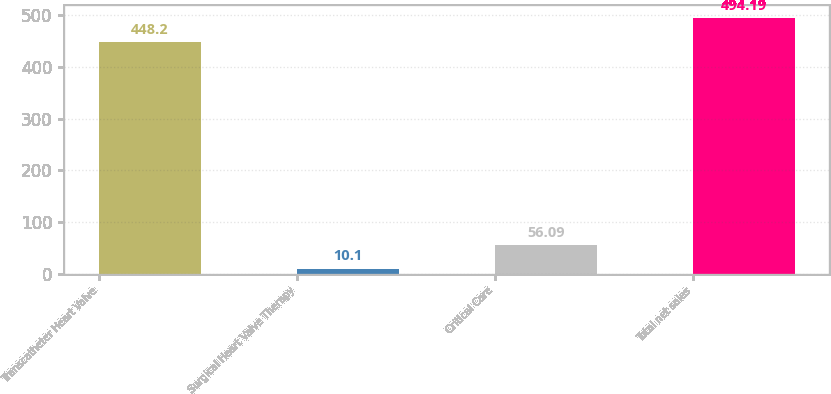<chart> <loc_0><loc_0><loc_500><loc_500><bar_chart><fcel>Transcatheter Heart Valve<fcel>Surgical Heart Valve Therapy<fcel>Critical Care<fcel>Total net sales<nl><fcel>448.2<fcel>10.1<fcel>56.09<fcel>494.19<nl></chart> 